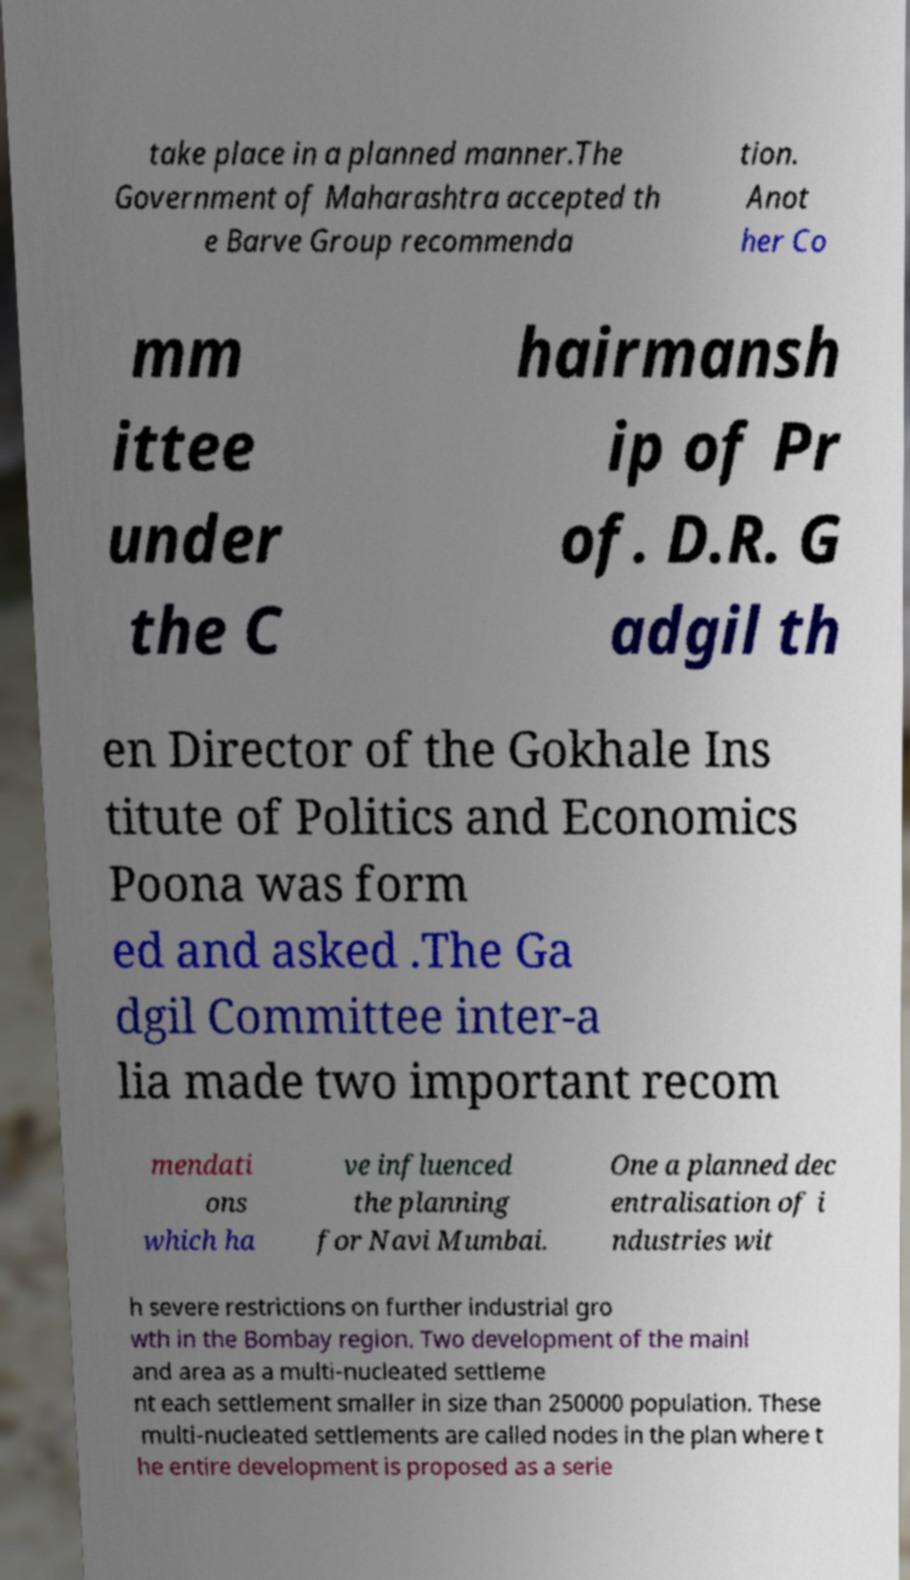Could you extract and type out the text from this image? take place in a planned manner.The Government of Maharashtra accepted th e Barve Group recommenda tion. Anot her Co mm ittee under the C hairmansh ip of Pr of. D.R. G adgil th en Director of the Gokhale Ins titute of Politics and Economics Poona was form ed and asked .The Ga dgil Committee inter-a lia made two important recom mendati ons which ha ve influenced the planning for Navi Mumbai. One a planned dec entralisation of i ndustries wit h severe restrictions on further industrial gro wth in the Bombay region. Two development of the mainl and area as a multi-nucleated settleme nt each settlement smaller in size than 250000 population. These multi-nucleated settlements are called nodes in the plan where t he entire development is proposed as a serie 